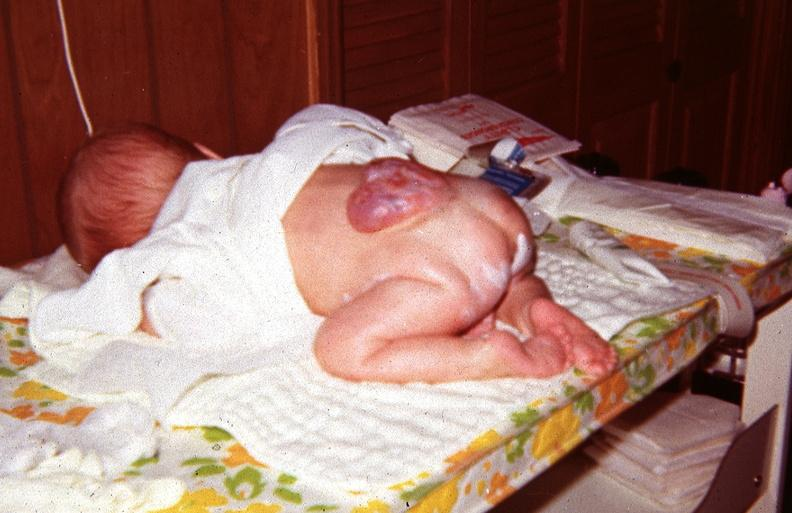does this image show neural tube defect?
Answer the question using a single word or phrase. Yes 